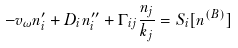<formula> <loc_0><loc_0><loc_500><loc_500>- v _ { \omega } n ^ { \prime } _ { i } + D _ { i } n ^ { \prime \prime } _ { i } + \Gamma _ { i j } \frac { n _ { j } } { k _ { j } } = S _ { i } [ n ^ { ( B ) } ]</formula> 